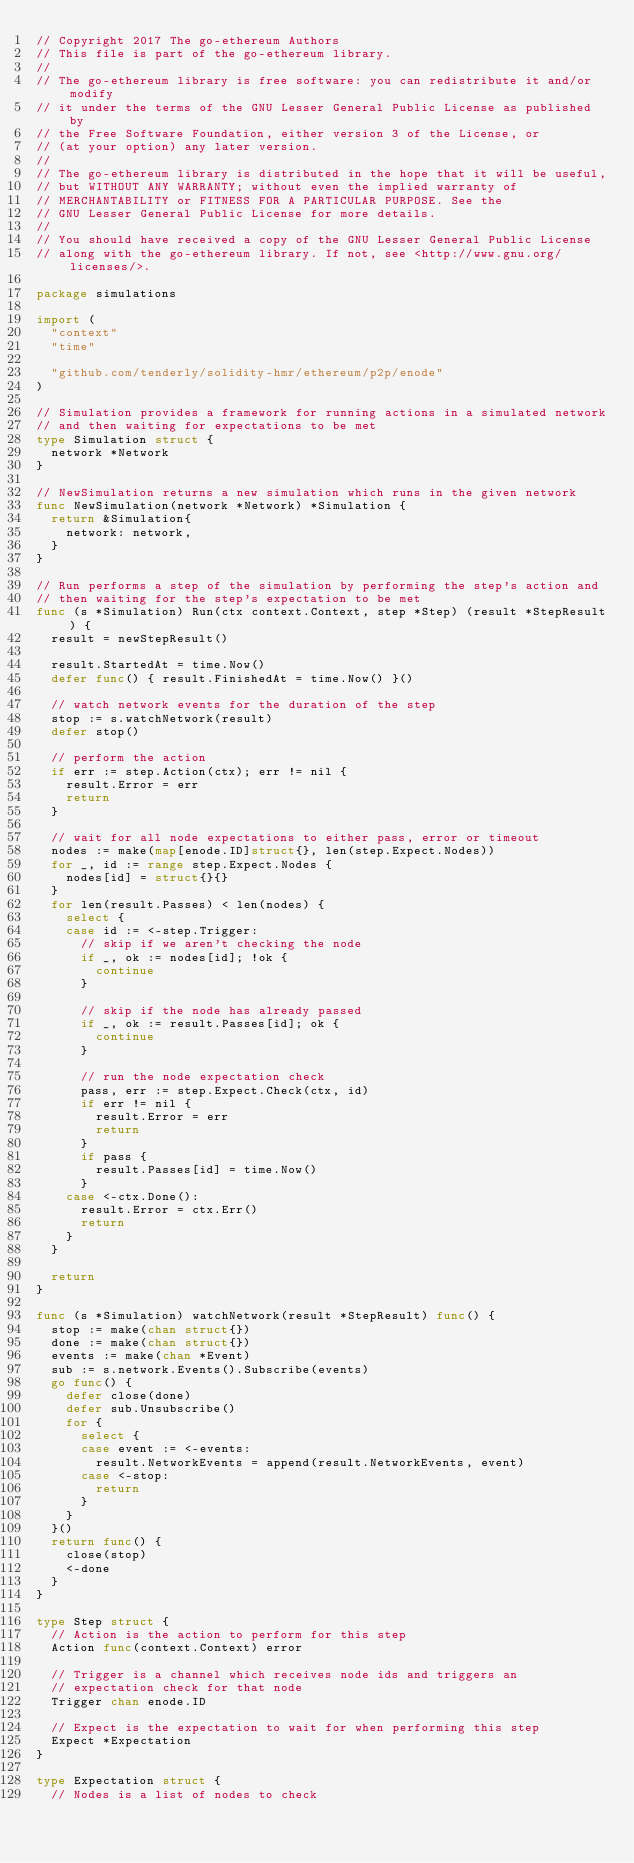<code> <loc_0><loc_0><loc_500><loc_500><_Go_>// Copyright 2017 The go-ethereum Authors
// This file is part of the go-ethereum library.
//
// The go-ethereum library is free software: you can redistribute it and/or modify
// it under the terms of the GNU Lesser General Public License as published by
// the Free Software Foundation, either version 3 of the License, or
// (at your option) any later version.
//
// The go-ethereum library is distributed in the hope that it will be useful,
// but WITHOUT ANY WARRANTY; without even the implied warranty of
// MERCHANTABILITY or FITNESS FOR A PARTICULAR PURPOSE. See the
// GNU Lesser General Public License for more details.
//
// You should have received a copy of the GNU Lesser General Public License
// along with the go-ethereum library. If not, see <http://www.gnu.org/licenses/>.

package simulations

import (
	"context"
	"time"

	"github.com/tenderly/solidity-hmr/ethereum/p2p/enode"
)

// Simulation provides a framework for running actions in a simulated network
// and then waiting for expectations to be met
type Simulation struct {
	network *Network
}

// NewSimulation returns a new simulation which runs in the given network
func NewSimulation(network *Network) *Simulation {
	return &Simulation{
		network: network,
	}
}

// Run performs a step of the simulation by performing the step's action and
// then waiting for the step's expectation to be met
func (s *Simulation) Run(ctx context.Context, step *Step) (result *StepResult) {
	result = newStepResult()

	result.StartedAt = time.Now()
	defer func() { result.FinishedAt = time.Now() }()

	// watch network events for the duration of the step
	stop := s.watchNetwork(result)
	defer stop()

	// perform the action
	if err := step.Action(ctx); err != nil {
		result.Error = err
		return
	}

	// wait for all node expectations to either pass, error or timeout
	nodes := make(map[enode.ID]struct{}, len(step.Expect.Nodes))
	for _, id := range step.Expect.Nodes {
		nodes[id] = struct{}{}
	}
	for len(result.Passes) < len(nodes) {
		select {
		case id := <-step.Trigger:
			// skip if we aren't checking the node
			if _, ok := nodes[id]; !ok {
				continue
			}

			// skip if the node has already passed
			if _, ok := result.Passes[id]; ok {
				continue
			}

			// run the node expectation check
			pass, err := step.Expect.Check(ctx, id)
			if err != nil {
				result.Error = err
				return
			}
			if pass {
				result.Passes[id] = time.Now()
			}
		case <-ctx.Done():
			result.Error = ctx.Err()
			return
		}
	}

	return
}

func (s *Simulation) watchNetwork(result *StepResult) func() {
	stop := make(chan struct{})
	done := make(chan struct{})
	events := make(chan *Event)
	sub := s.network.Events().Subscribe(events)
	go func() {
		defer close(done)
		defer sub.Unsubscribe()
		for {
			select {
			case event := <-events:
				result.NetworkEvents = append(result.NetworkEvents, event)
			case <-stop:
				return
			}
		}
	}()
	return func() {
		close(stop)
		<-done
	}
}

type Step struct {
	// Action is the action to perform for this step
	Action func(context.Context) error

	// Trigger is a channel which receives node ids and triggers an
	// expectation check for that node
	Trigger chan enode.ID

	// Expect is the expectation to wait for when performing this step
	Expect *Expectation
}

type Expectation struct {
	// Nodes is a list of nodes to check</code> 